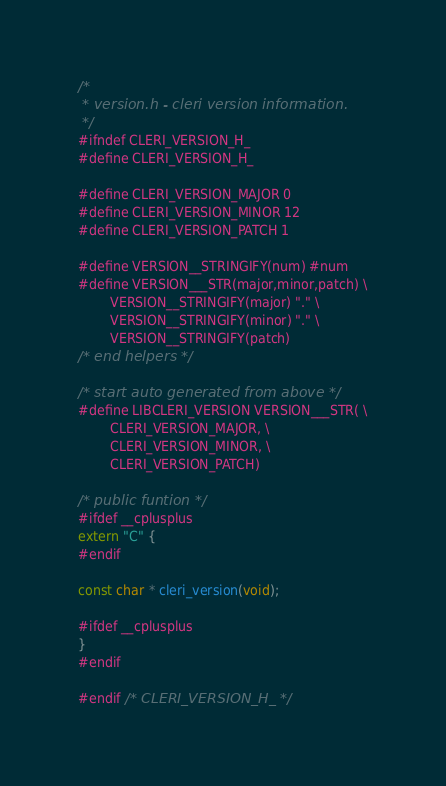Convert code to text. <code><loc_0><loc_0><loc_500><loc_500><_C_>/*
 * version.h - cleri version information.
 */
#ifndef CLERI_VERSION_H_
#define CLERI_VERSION_H_

#define CLERI_VERSION_MAJOR 0
#define CLERI_VERSION_MINOR 12
#define CLERI_VERSION_PATCH 1

#define VERSION__STRINGIFY(num) #num
#define VERSION___STR(major,minor,patch) \
        VERSION__STRINGIFY(major) "." \
        VERSION__STRINGIFY(minor) "." \
        VERSION__STRINGIFY(patch)
/* end helpers */

/* start auto generated from above */
#define LIBCLERI_VERSION VERSION___STR( \
        CLERI_VERSION_MAJOR, \
        CLERI_VERSION_MINOR, \
        CLERI_VERSION_PATCH)

/* public funtion */
#ifdef __cplusplus
extern "C" {
#endif

const char * cleri_version(void);

#ifdef __cplusplus
}
#endif

#endif /* CLERI_VERSION_H_ */
</code> 